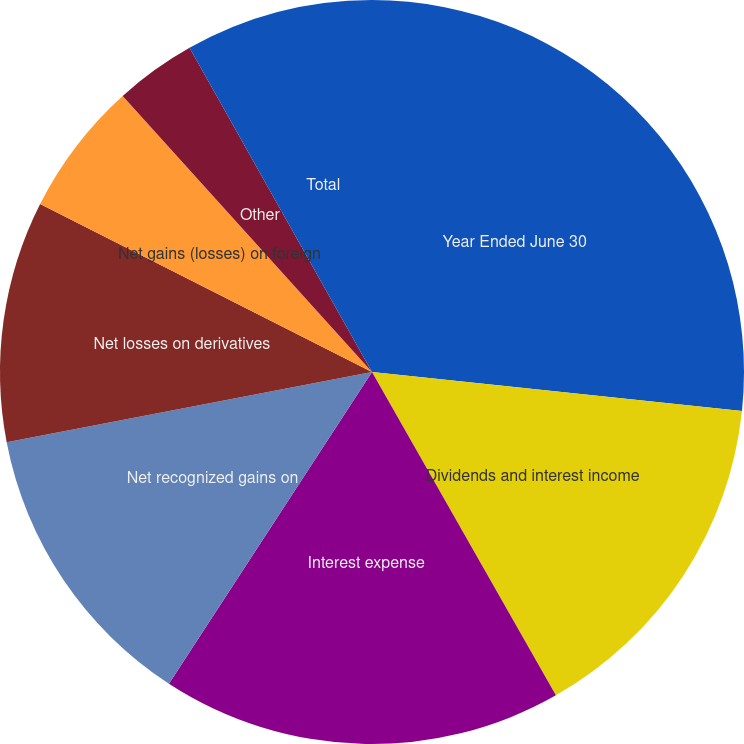Convert chart to OTSL. <chart><loc_0><loc_0><loc_500><loc_500><pie_chart><fcel>Year Ended June 30<fcel>Dividends and interest income<fcel>Interest expense<fcel>Net recognized gains on<fcel>Net losses on derivatives<fcel>Net gains (losses) on foreign<fcel>Other<fcel>Total<nl><fcel>26.67%<fcel>15.1%<fcel>17.42%<fcel>12.79%<fcel>10.48%<fcel>5.85%<fcel>3.53%<fcel>8.16%<nl></chart> 